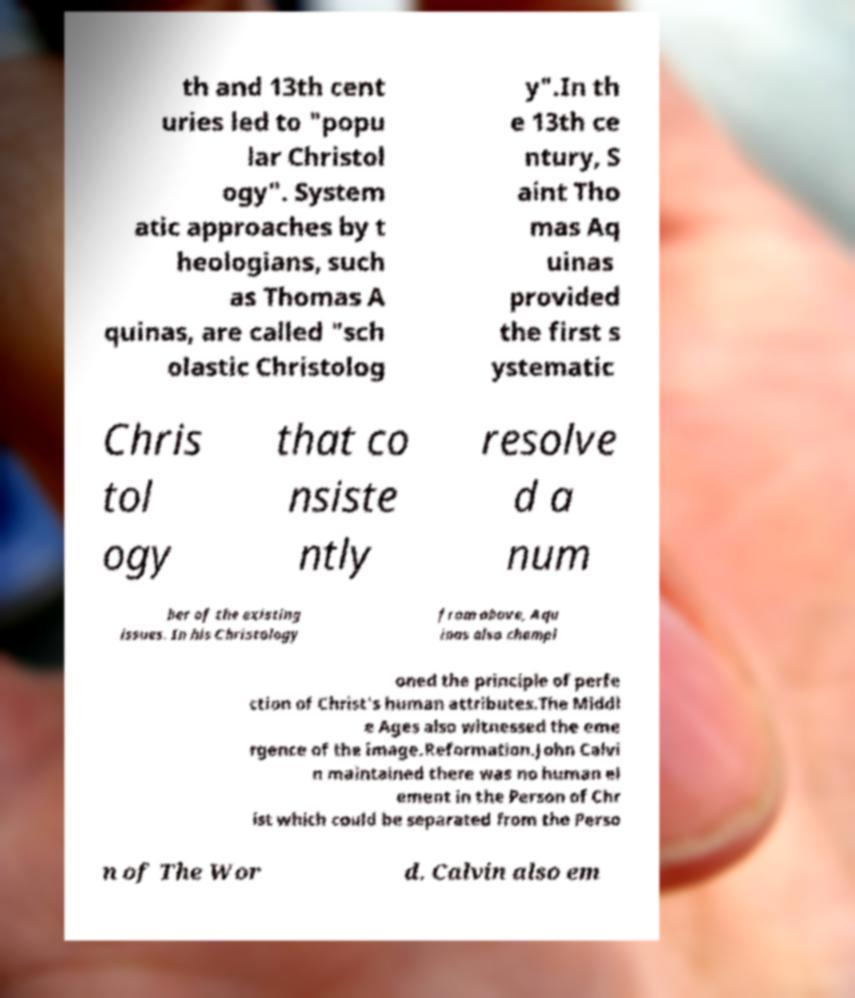Can you accurately transcribe the text from the provided image for me? th and 13th cent uries led to "popu lar Christol ogy". System atic approaches by t heologians, such as Thomas A quinas, are called "sch olastic Christolog y".In th e 13th ce ntury, S aint Tho mas Aq uinas provided the first s ystematic Chris tol ogy that co nsiste ntly resolve d a num ber of the existing issues. In his Christology from above, Aqu inas also champi oned the principle of perfe ction of Christ's human attributes.The Middl e Ages also witnessed the eme rgence of the image.Reformation.John Calvi n maintained there was no human el ement in the Person of Chr ist which could be separated from the Perso n of The Wor d. Calvin also em 